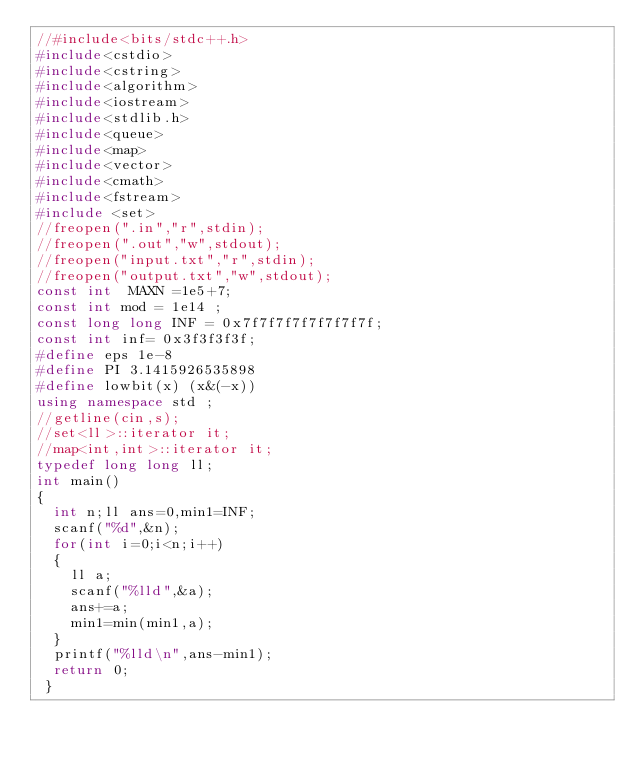Convert code to text. <code><loc_0><loc_0><loc_500><loc_500><_C++_>//#include<bits/stdc++.h>
#include<cstdio>
#include<cstring>
#include<algorithm>
#include<iostream>
#include<stdlib.h>
#include<queue>
#include<map>
#include<vector>
#include<cmath>
#include<fstream>
#include <set>
//freopen(".in","r",stdin);
//freopen(".out","w",stdout);
//freopen("input.txt","r",stdin);
//freopen("output.txt","w",stdout);
const int  MAXN =1e5+7;
const int mod = 1e14 ;
const long long INF = 0x7f7f7f7f7f7f7f7f;
const int inf= 0x3f3f3f3f;
#define eps 1e-8
#define PI 3.1415926535898
#define lowbit(x) (x&(-x))
using namespace std ;
//getline(cin,s);
//set<ll>::iterator it;
//map<int,int>::iterator it;
typedef long long ll;
int main()
{
	int n;ll ans=0,min1=INF;
	scanf("%d",&n);
	for(int i=0;i<n;i++)
	{
		ll a;
		scanf("%lld",&a);
		ans+=a;
		min1=min(min1,a);
	}
	printf("%lld\n",ans-min1);
	return 0;
 } </code> 